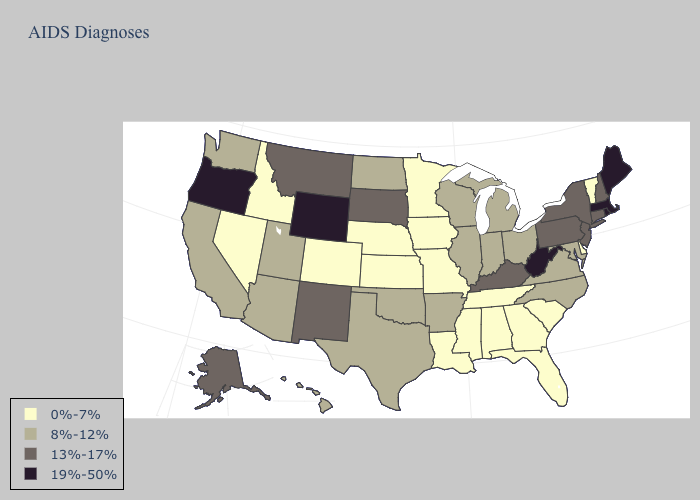Does Rhode Island have the highest value in the USA?
Write a very short answer. Yes. What is the lowest value in the USA?
Short answer required. 0%-7%. Name the states that have a value in the range 13%-17%?
Give a very brief answer. Alaska, Connecticut, Kentucky, Montana, New Hampshire, New Jersey, New Mexico, New York, Pennsylvania, South Dakota. Name the states that have a value in the range 19%-50%?
Give a very brief answer. Maine, Massachusetts, Oregon, Rhode Island, West Virginia, Wyoming. What is the highest value in states that border Oklahoma?
Short answer required. 13%-17%. What is the lowest value in the USA?
Keep it brief. 0%-7%. Does Florida have a higher value than Washington?
Concise answer only. No. Does Tennessee have the lowest value in the South?
Keep it brief. Yes. Name the states that have a value in the range 0%-7%?
Short answer required. Alabama, Colorado, Delaware, Florida, Georgia, Idaho, Iowa, Kansas, Louisiana, Minnesota, Mississippi, Missouri, Nebraska, Nevada, South Carolina, Tennessee, Vermont. Which states hav the highest value in the MidWest?
Quick response, please. South Dakota. Among the states that border Kentucky , which have the highest value?
Write a very short answer. West Virginia. Among the states that border South Carolina , does North Carolina have the highest value?
Short answer required. Yes. What is the value of Alaska?
Short answer required. 13%-17%. What is the value of Maryland?
Keep it brief. 8%-12%. What is the highest value in states that border Georgia?
Quick response, please. 8%-12%. 